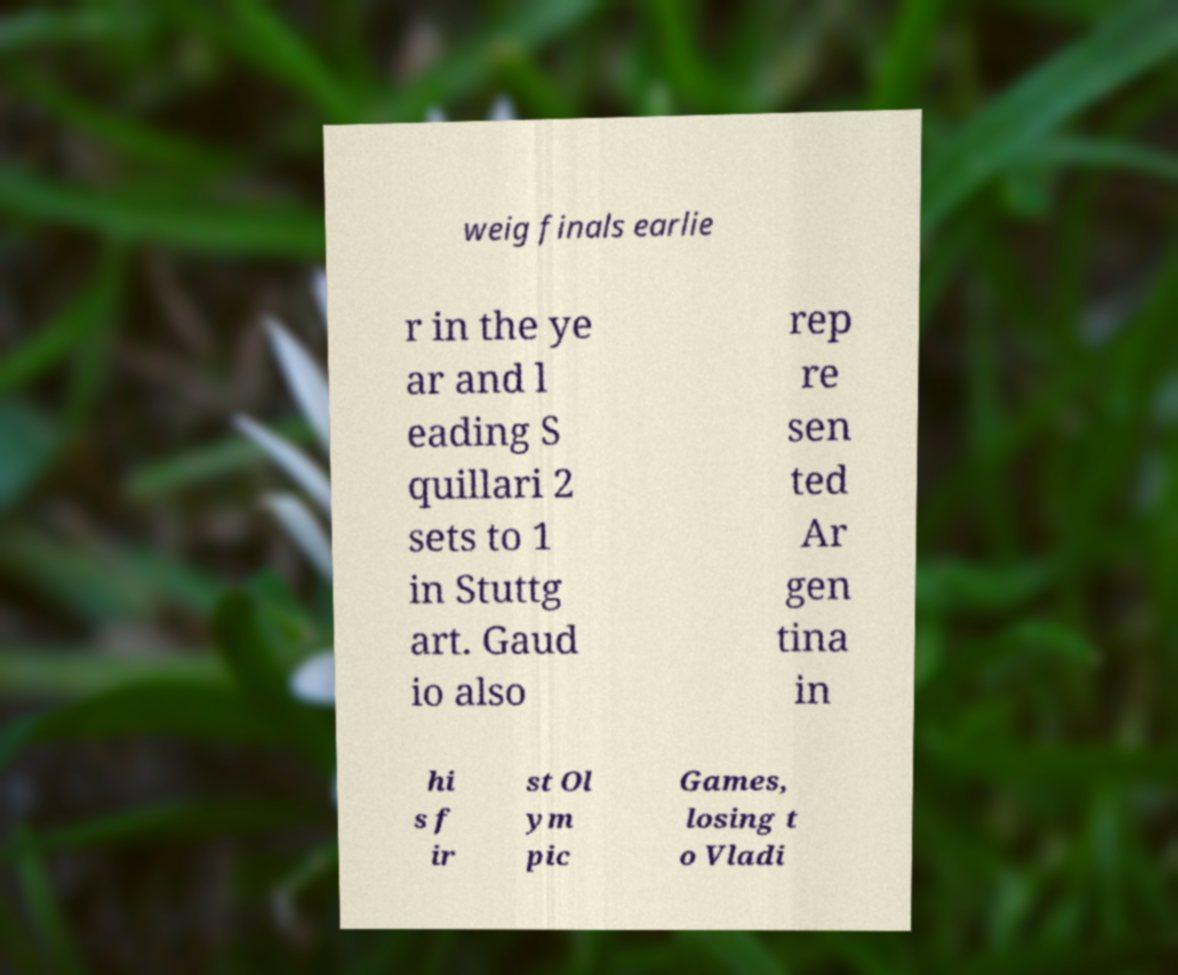Please read and relay the text visible in this image. What does it say? weig finals earlie r in the ye ar and l eading S quillari 2 sets to 1 in Stuttg art. Gaud io also rep re sen ted Ar gen tina in hi s f ir st Ol ym pic Games, losing t o Vladi 